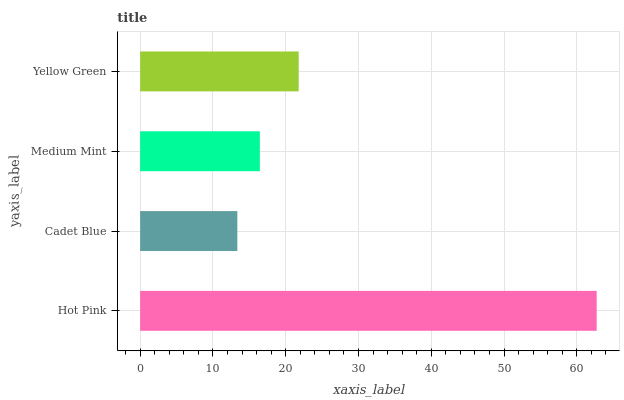Is Cadet Blue the minimum?
Answer yes or no. Yes. Is Hot Pink the maximum?
Answer yes or no. Yes. Is Medium Mint the minimum?
Answer yes or no. No. Is Medium Mint the maximum?
Answer yes or no. No. Is Medium Mint greater than Cadet Blue?
Answer yes or no. Yes. Is Cadet Blue less than Medium Mint?
Answer yes or no. Yes. Is Cadet Blue greater than Medium Mint?
Answer yes or no. No. Is Medium Mint less than Cadet Blue?
Answer yes or no. No. Is Yellow Green the high median?
Answer yes or no. Yes. Is Medium Mint the low median?
Answer yes or no. Yes. Is Cadet Blue the high median?
Answer yes or no. No. Is Hot Pink the low median?
Answer yes or no. No. 